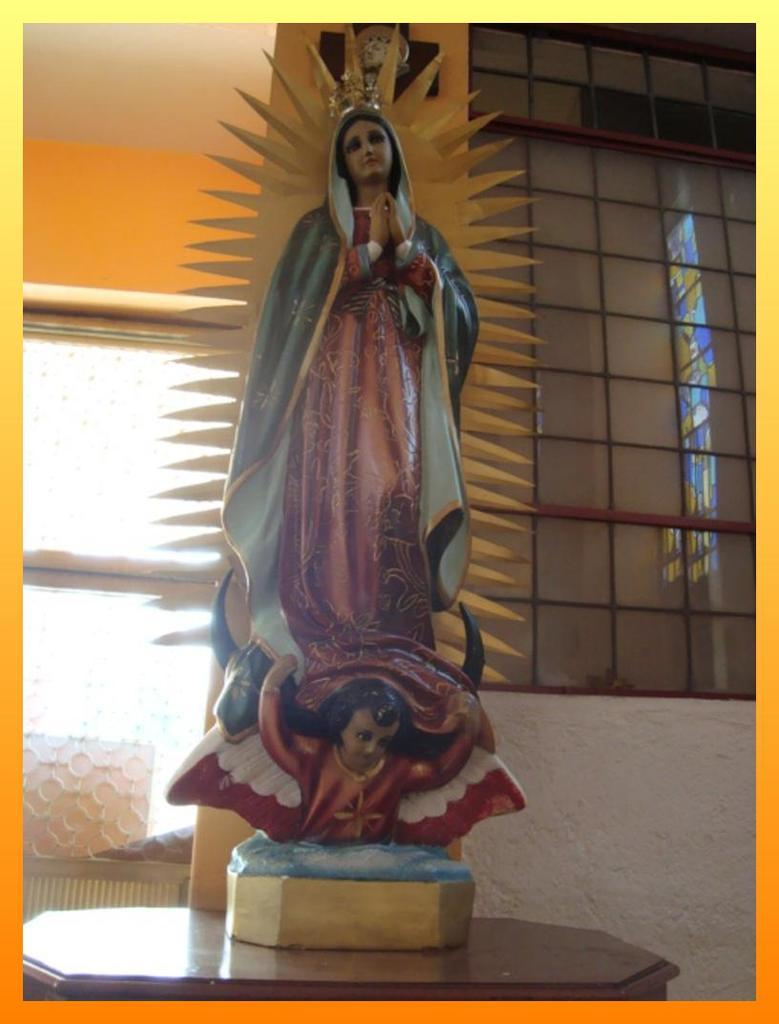What is the main subject on the table in the image? There is a statue on a table in the image. What is behind the statue on the table? There is a wall with mirrors behind the statue. What can be seen at the top of the image? A ceiling is visible at the top of the image. What time-telling device is hanging on the wall in the image? A clock is hanging on the wall in the image. How many cars are parked in front of the statue in the image? There are no cars visible in the image; it only shows a statue on a table with a wall of mirrors behind it, a ceiling, and a clock hanging on the wall. 